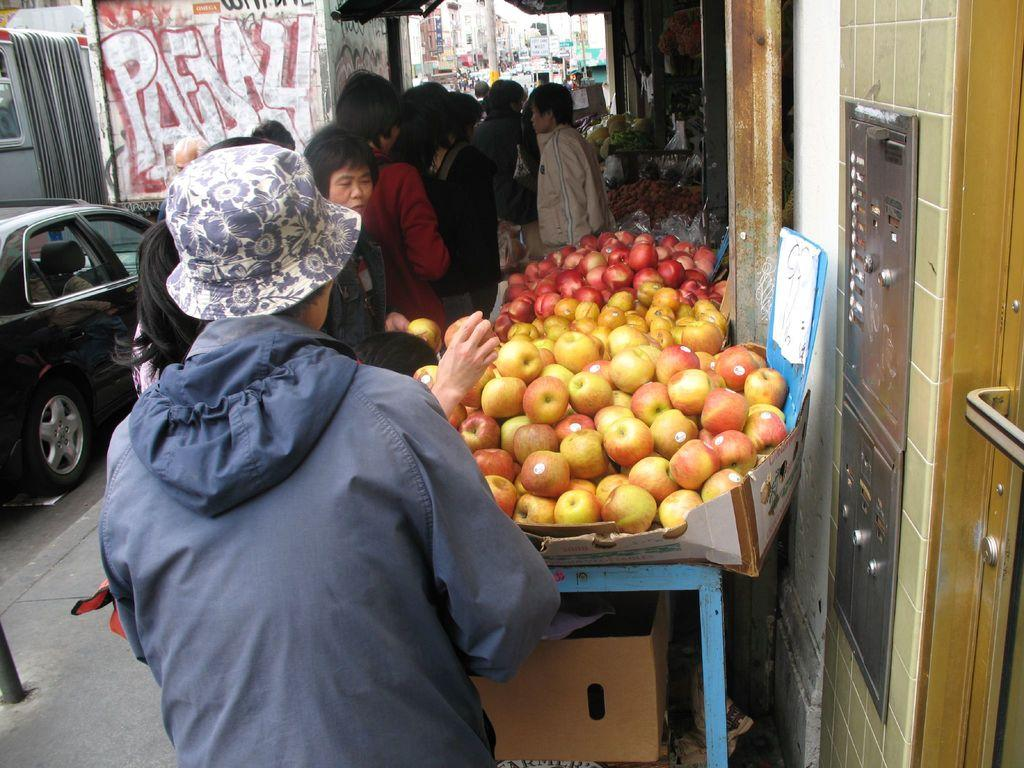What type of fruit is on the table in the image? There are apples on the table in the image. Where is the table located in relation to other objects or structures? The table is beside a wall. What can be seen near the table? There are people standing beside the table. What type of vehicle is visible in the image? There is a car in the image. What type of structure is visible in the image? There is a building in the image. What type of jam is being spread on the apples in the image? There is no jam present in the image. 